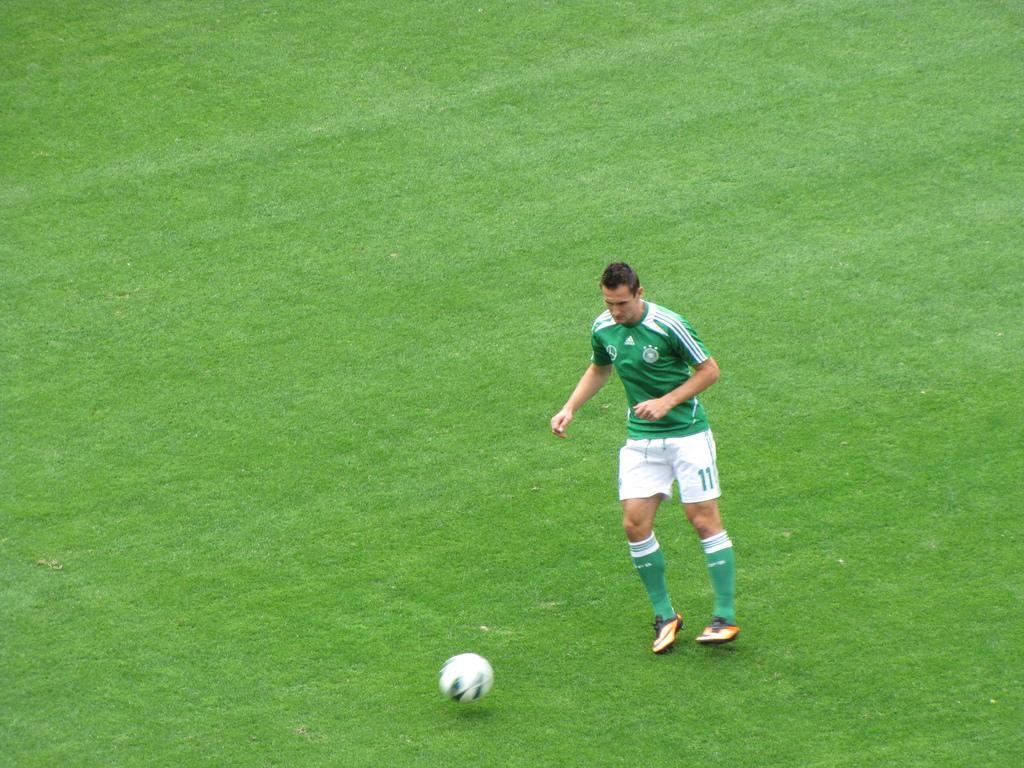What is the number of this player?
Your response must be concise. 11. 